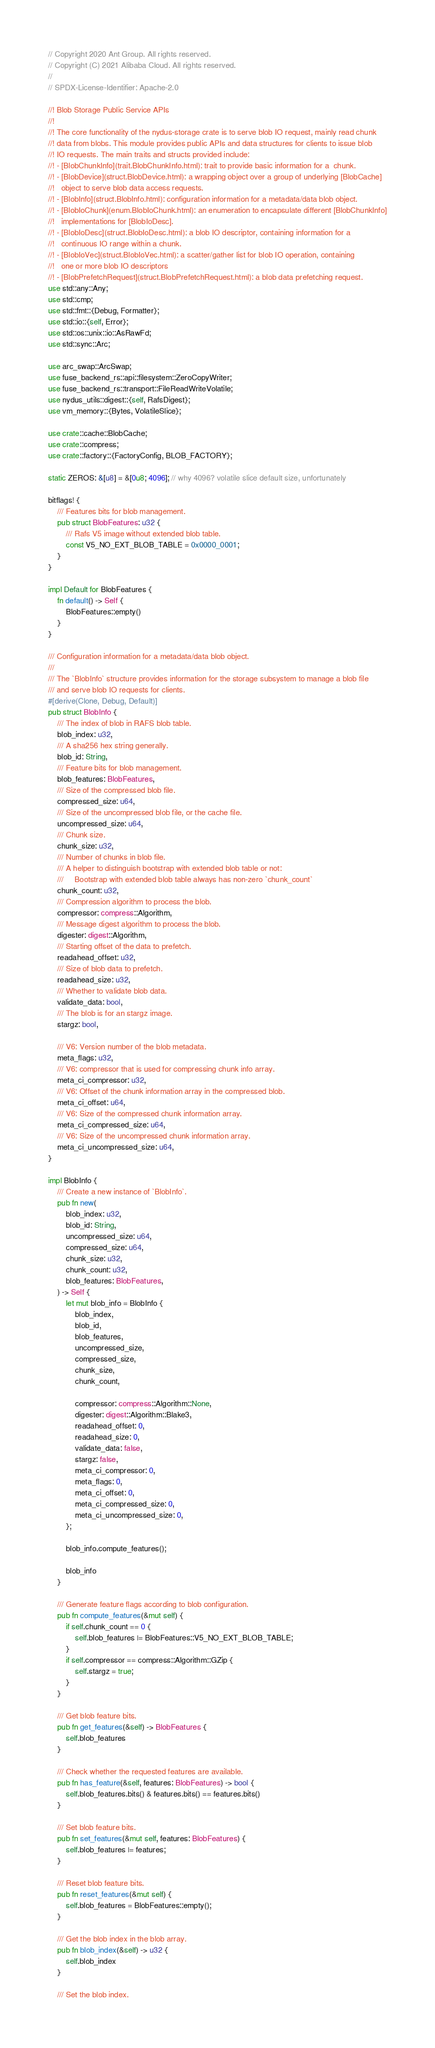<code> <loc_0><loc_0><loc_500><loc_500><_Rust_>// Copyright 2020 Ant Group. All rights reserved.
// Copyright (C) 2021 Alibaba Cloud. All rights reserved.
//
// SPDX-License-Identifier: Apache-2.0

//! Blob Storage Public Service APIs
//!
//! The core functionality of the nydus-storage crate is to serve blob IO request, mainly read chunk
//! data from blobs. This module provides public APIs and data structures for clients to issue blob
//! IO requests. The main traits and structs provided include:
//! - [BlobChunkInfo](trait.BlobChunkInfo.html): trait to provide basic information for a  chunk.
//! - [BlobDevice](struct.BlobDevice.html): a wrapping object over a group of underlying [BlobCache]
//!   object to serve blob data access requests.
//! - [BlobInfo](struct.BlobInfo.html): configuration information for a metadata/data blob object.
//! - [BlobIoChunk](enum.BlobIoChunk.html): an enumeration to encapsulate different [BlobChunkInfo]
//!   implementations for [BlobIoDesc].
//! - [BlobIoDesc](struct.BlobIoDesc.html): a blob IO descriptor, containing information for a
//!   continuous IO range within a chunk.
//! - [BlobIoVec](struct.BlobIoVec.html): a scatter/gather list for blob IO operation, containing
//!   one or more blob IO descriptors
//! - [BlobPrefetchRequest](struct.BlobPrefetchRequest.html): a blob data prefetching request.
use std::any::Any;
use std::cmp;
use std::fmt::{Debug, Formatter};
use std::io::{self, Error};
use std::os::unix::io::AsRawFd;
use std::sync::Arc;

use arc_swap::ArcSwap;
use fuse_backend_rs::api::filesystem::ZeroCopyWriter;
use fuse_backend_rs::transport::FileReadWriteVolatile;
use nydus_utils::digest::{self, RafsDigest};
use vm_memory::{Bytes, VolatileSlice};

use crate::cache::BlobCache;
use crate::compress;
use crate::factory::{FactoryConfig, BLOB_FACTORY};

static ZEROS: &[u8] = &[0u8; 4096]; // why 4096? volatile slice default size, unfortunately

bitflags! {
    /// Features bits for blob management.
    pub struct BlobFeatures: u32 {
        /// Rafs V5 image without extended blob table.
        const V5_NO_EXT_BLOB_TABLE = 0x0000_0001;
    }
}

impl Default for BlobFeatures {
    fn default() -> Self {
        BlobFeatures::empty()
    }
}

/// Configuration information for a metadata/data blob object.
///
/// The `BlobInfo` structure provides information for the storage subsystem to manage a blob file
/// and serve blob IO requests for clients.
#[derive(Clone, Debug, Default)]
pub struct BlobInfo {
    /// The index of blob in RAFS blob table.
    blob_index: u32,
    /// A sha256 hex string generally.
    blob_id: String,
    /// Feature bits for blob management.
    blob_features: BlobFeatures,
    /// Size of the compressed blob file.
    compressed_size: u64,
    /// Size of the uncompressed blob file, or the cache file.
    uncompressed_size: u64,
    /// Chunk size.
    chunk_size: u32,
    /// Number of chunks in blob file.
    /// A helper to distinguish bootstrap with extended blob table or not:
    ///     Bootstrap with extended blob table always has non-zero `chunk_count`
    chunk_count: u32,
    /// Compression algorithm to process the blob.
    compressor: compress::Algorithm,
    /// Message digest algorithm to process the blob.
    digester: digest::Algorithm,
    /// Starting offset of the data to prefetch.
    readahead_offset: u32,
    /// Size of blob data to prefetch.
    readahead_size: u32,
    /// Whether to validate blob data.
    validate_data: bool,
    /// The blob is for an stargz image.
    stargz: bool,

    /// V6: Version number of the blob metadata.
    meta_flags: u32,
    /// V6: compressor that is used for compressing chunk info array.
    meta_ci_compressor: u32,
    /// V6: Offset of the chunk information array in the compressed blob.
    meta_ci_offset: u64,
    /// V6: Size of the compressed chunk information array.
    meta_ci_compressed_size: u64,
    /// V6: Size of the uncompressed chunk information array.
    meta_ci_uncompressed_size: u64,
}

impl BlobInfo {
    /// Create a new instance of `BlobInfo`.
    pub fn new(
        blob_index: u32,
        blob_id: String,
        uncompressed_size: u64,
        compressed_size: u64,
        chunk_size: u32,
        chunk_count: u32,
        blob_features: BlobFeatures,
    ) -> Self {
        let mut blob_info = BlobInfo {
            blob_index,
            blob_id,
            blob_features,
            uncompressed_size,
            compressed_size,
            chunk_size,
            chunk_count,

            compressor: compress::Algorithm::None,
            digester: digest::Algorithm::Blake3,
            readahead_offset: 0,
            readahead_size: 0,
            validate_data: false,
            stargz: false,
            meta_ci_compressor: 0,
            meta_flags: 0,
            meta_ci_offset: 0,
            meta_ci_compressed_size: 0,
            meta_ci_uncompressed_size: 0,
        };

        blob_info.compute_features();

        blob_info
    }

    /// Generate feature flags according to blob configuration.
    pub fn compute_features(&mut self) {
        if self.chunk_count == 0 {
            self.blob_features |= BlobFeatures::V5_NO_EXT_BLOB_TABLE;
        }
        if self.compressor == compress::Algorithm::GZip {
            self.stargz = true;
        }
    }

    /// Get blob feature bits.
    pub fn get_features(&self) -> BlobFeatures {
        self.blob_features
    }

    /// Check whether the requested features are available.
    pub fn has_feature(&self, features: BlobFeatures) -> bool {
        self.blob_features.bits() & features.bits() == features.bits()
    }

    /// Set blob feature bits.
    pub fn set_features(&mut self, features: BlobFeatures) {
        self.blob_features |= features;
    }

    /// Reset blob feature bits.
    pub fn reset_features(&mut self) {
        self.blob_features = BlobFeatures::empty();
    }

    /// Get the blob index in the blob array.
    pub fn blob_index(&self) -> u32 {
        self.blob_index
    }

    /// Set the blob index.</code> 